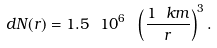<formula> <loc_0><loc_0><loc_500><loc_500>d N ( r ) = 1 . 5 \ 1 0 ^ { 6 } \ \left ( \frac { 1 \ k m } { r } \right ) ^ { 3 } .</formula> 